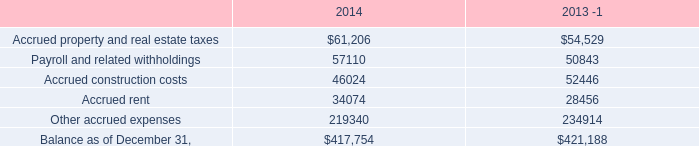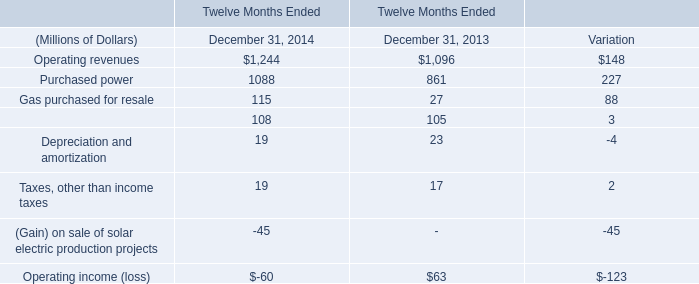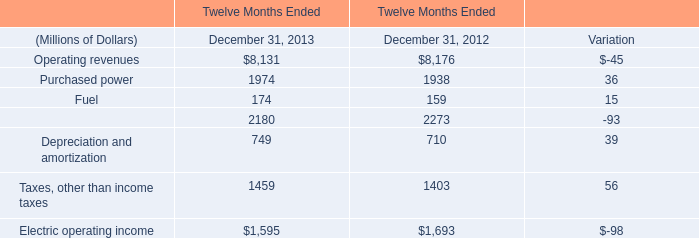What will purchase power reach in 2013 if it continues to grow at its current rate? (in million) 
Computations: (((36 / 1938) + 1) * 1974)
Answer: 2010.66873. 